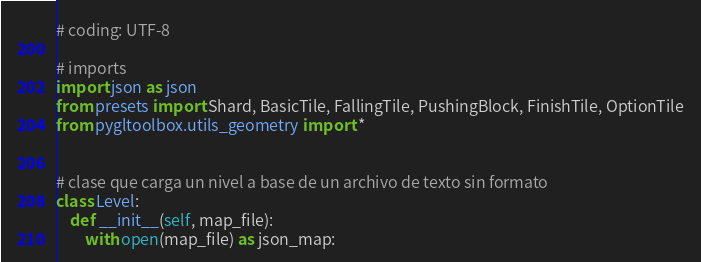Convert code to text. <code><loc_0><loc_0><loc_500><loc_500><_Python_># coding: UTF-8

# imports
import json as json
from presets import Shard, BasicTile, FallingTile, PushingBlock, FinishTile, OptionTile
from pygltoolbox.utils_geometry import *


# clase que carga un nivel a base de un archivo de texto sin formato
class Level:
    def __init__(self, map_file):
        with open(map_file) as json_map:</code> 